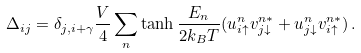Convert formula to latex. <formula><loc_0><loc_0><loc_500><loc_500>\Delta _ { i j } = \delta _ { j , i + \gamma } \frac { V } { 4 } \sum _ { n } \tanh \frac { E _ { n } } { 2 k _ { B } T } ( u ^ { n } _ { i \uparrow } v ^ { n * } _ { j \downarrow } + u ^ { n } _ { j \downarrow } v ^ { n * } _ { i \uparrow } ) \, .</formula> 